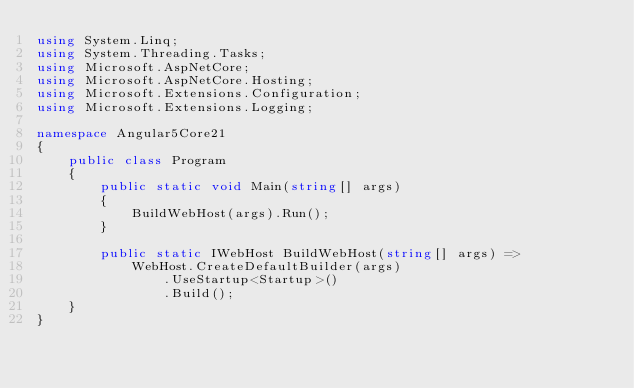<code> <loc_0><loc_0><loc_500><loc_500><_C#_>using System.Linq;
using System.Threading.Tasks;
using Microsoft.AspNetCore;
using Microsoft.AspNetCore.Hosting;
using Microsoft.Extensions.Configuration;
using Microsoft.Extensions.Logging;

namespace Angular5Core21
{
    public class Program
    {
        public static void Main(string[] args)
        {
            BuildWebHost(args).Run();
        }

        public static IWebHost BuildWebHost(string[] args) =>
            WebHost.CreateDefaultBuilder(args)
                .UseStartup<Startup>()
                .Build();
    }
}
</code> 